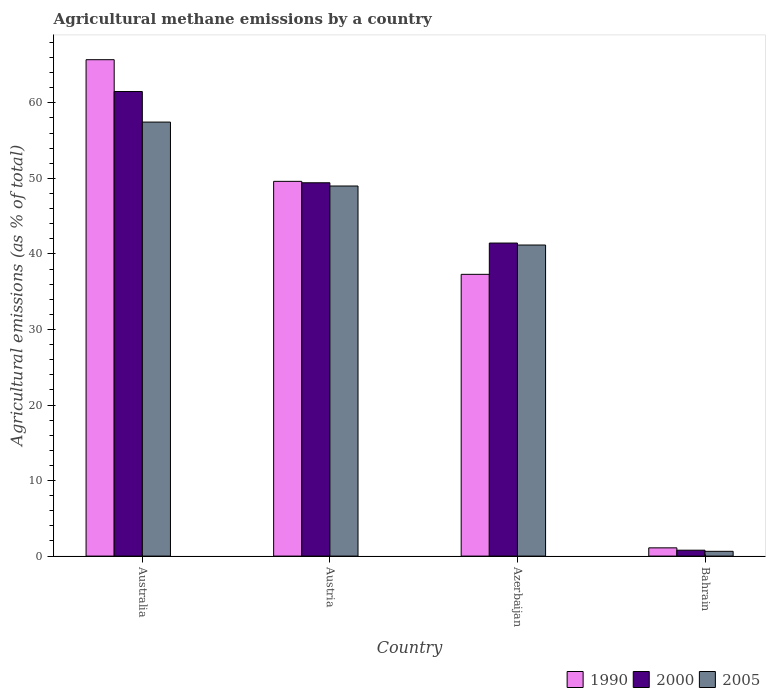Are the number of bars per tick equal to the number of legend labels?
Keep it short and to the point. Yes. How many bars are there on the 4th tick from the right?
Offer a very short reply. 3. What is the label of the 3rd group of bars from the left?
Give a very brief answer. Azerbaijan. In how many cases, is the number of bars for a given country not equal to the number of legend labels?
Offer a terse response. 0. What is the amount of agricultural methane emitted in 2005 in Austria?
Make the answer very short. 48.99. Across all countries, what is the maximum amount of agricultural methane emitted in 2005?
Offer a terse response. 57.45. Across all countries, what is the minimum amount of agricultural methane emitted in 2005?
Provide a short and direct response. 0.63. In which country was the amount of agricultural methane emitted in 1990 maximum?
Your answer should be very brief. Australia. In which country was the amount of agricultural methane emitted in 2005 minimum?
Provide a short and direct response. Bahrain. What is the total amount of agricultural methane emitted in 1990 in the graph?
Your answer should be compact. 153.71. What is the difference between the amount of agricultural methane emitted in 2005 in Australia and that in Bahrain?
Give a very brief answer. 56.82. What is the difference between the amount of agricultural methane emitted in 2005 in Azerbaijan and the amount of agricultural methane emitted in 1990 in Bahrain?
Offer a terse response. 40.09. What is the average amount of agricultural methane emitted in 2000 per country?
Give a very brief answer. 38.28. What is the difference between the amount of agricultural methane emitted of/in 2005 and amount of agricultural methane emitted of/in 2000 in Austria?
Offer a very short reply. -0.43. In how many countries, is the amount of agricultural methane emitted in 2005 greater than 44 %?
Provide a short and direct response. 2. What is the ratio of the amount of agricultural methane emitted in 2000 in Austria to that in Azerbaijan?
Make the answer very short. 1.19. What is the difference between the highest and the second highest amount of agricultural methane emitted in 2005?
Keep it short and to the point. -8.46. What is the difference between the highest and the lowest amount of agricultural methane emitted in 1990?
Ensure brevity in your answer.  64.62. In how many countries, is the amount of agricultural methane emitted in 1990 greater than the average amount of agricultural methane emitted in 1990 taken over all countries?
Offer a very short reply. 2. Is it the case that in every country, the sum of the amount of agricultural methane emitted in 2005 and amount of agricultural methane emitted in 1990 is greater than the amount of agricultural methane emitted in 2000?
Make the answer very short. Yes. How many bars are there?
Your answer should be compact. 12. Are the values on the major ticks of Y-axis written in scientific E-notation?
Your answer should be very brief. No. Does the graph contain grids?
Offer a very short reply. No. How are the legend labels stacked?
Offer a very short reply. Horizontal. What is the title of the graph?
Make the answer very short. Agricultural methane emissions by a country. What is the label or title of the Y-axis?
Your answer should be very brief. Agricultural emissions (as % of total). What is the Agricultural emissions (as % of total) of 1990 in Australia?
Your answer should be compact. 65.71. What is the Agricultural emissions (as % of total) of 2000 in Australia?
Give a very brief answer. 61.5. What is the Agricultural emissions (as % of total) in 2005 in Australia?
Provide a short and direct response. 57.45. What is the Agricultural emissions (as % of total) in 1990 in Austria?
Offer a terse response. 49.61. What is the Agricultural emissions (as % of total) of 2000 in Austria?
Provide a short and direct response. 49.42. What is the Agricultural emissions (as % of total) in 2005 in Austria?
Give a very brief answer. 48.99. What is the Agricultural emissions (as % of total) in 1990 in Azerbaijan?
Your response must be concise. 37.3. What is the Agricultural emissions (as % of total) in 2000 in Azerbaijan?
Your answer should be compact. 41.44. What is the Agricultural emissions (as % of total) in 2005 in Azerbaijan?
Keep it short and to the point. 41.18. What is the Agricultural emissions (as % of total) in 1990 in Bahrain?
Your answer should be compact. 1.09. What is the Agricultural emissions (as % of total) of 2000 in Bahrain?
Provide a short and direct response. 0.78. What is the Agricultural emissions (as % of total) of 2005 in Bahrain?
Your response must be concise. 0.63. Across all countries, what is the maximum Agricultural emissions (as % of total) in 1990?
Your response must be concise. 65.71. Across all countries, what is the maximum Agricultural emissions (as % of total) in 2000?
Offer a very short reply. 61.5. Across all countries, what is the maximum Agricultural emissions (as % of total) in 2005?
Give a very brief answer. 57.45. Across all countries, what is the minimum Agricultural emissions (as % of total) in 1990?
Keep it short and to the point. 1.09. Across all countries, what is the minimum Agricultural emissions (as % of total) in 2000?
Your response must be concise. 0.78. Across all countries, what is the minimum Agricultural emissions (as % of total) of 2005?
Provide a short and direct response. 0.63. What is the total Agricultural emissions (as % of total) in 1990 in the graph?
Your answer should be very brief. 153.71. What is the total Agricultural emissions (as % of total) in 2000 in the graph?
Make the answer very short. 153.13. What is the total Agricultural emissions (as % of total) of 2005 in the graph?
Offer a terse response. 148.25. What is the difference between the Agricultural emissions (as % of total) in 1990 in Australia and that in Austria?
Keep it short and to the point. 16.1. What is the difference between the Agricultural emissions (as % of total) in 2000 in Australia and that in Austria?
Ensure brevity in your answer.  12.08. What is the difference between the Agricultural emissions (as % of total) in 2005 in Australia and that in Austria?
Give a very brief answer. 8.46. What is the difference between the Agricultural emissions (as % of total) in 1990 in Australia and that in Azerbaijan?
Your response must be concise. 28.41. What is the difference between the Agricultural emissions (as % of total) in 2000 in Australia and that in Azerbaijan?
Give a very brief answer. 20.06. What is the difference between the Agricultural emissions (as % of total) in 2005 in Australia and that in Azerbaijan?
Make the answer very short. 16.27. What is the difference between the Agricultural emissions (as % of total) of 1990 in Australia and that in Bahrain?
Your answer should be very brief. 64.62. What is the difference between the Agricultural emissions (as % of total) of 2000 in Australia and that in Bahrain?
Give a very brief answer. 60.72. What is the difference between the Agricultural emissions (as % of total) in 2005 in Australia and that in Bahrain?
Offer a terse response. 56.82. What is the difference between the Agricultural emissions (as % of total) in 1990 in Austria and that in Azerbaijan?
Make the answer very short. 12.31. What is the difference between the Agricultural emissions (as % of total) of 2000 in Austria and that in Azerbaijan?
Provide a succinct answer. 7.98. What is the difference between the Agricultural emissions (as % of total) of 2005 in Austria and that in Azerbaijan?
Offer a very short reply. 7.81. What is the difference between the Agricultural emissions (as % of total) of 1990 in Austria and that in Bahrain?
Ensure brevity in your answer.  48.51. What is the difference between the Agricultural emissions (as % of total) in 2000 in Austria and that in Bahrain?
Provide a short and direct response. 48.64. What is the difference between the Agricultural emissions (as % of total) in 2005 in Austria and that in Bahrain?
Your answer should be very brief. 48.36. What is the difference between the Agricultural emissions (as % of total) of 1990 in Azerbaijan and that in Bahrain?
Your answer should be very brief. 36.21. What is the difference between the Agricultural emissions (as % of total) of 2000 in Azerbaijan and that in Bahrain?
Provide a short and direct response. 40.66. What is the difference between the Agricultural emissions (as % of total) in 2005 in Azerbaijan and that in Bahrain?
Your answer should be very brief. 40.54. What is the difference between the Agricultural emissions (as % of total) in 1990 in Australia and the Agricultural emissions (as % of total) in 2000 in Austria?
Make the answer very short. 16.29. What is the difference between the Agricultural emissions (as % of total) of 1990 in Australia and the Agricultural emissions (as % of total) of 2005 in Austria?
Your answer should be compact. 16.72. What is the difference between the Agricultural emissions (as % of total) of 2000 in Australia and the Agricultural emissions (as % of total) of 2005 in Austria?
Your answer should be compact. 12.51. What is the difference between the Agricultural emissions (as % of total) of 1990 in Australia and the Agricultural emissions (as % of total) of 2000 in Azerbaijan?
Offer a very short reply. 24.27. What is the difference between the Agricultural emissions (as % of total) of 1990 in Australia and the Agricultural emissions (as % of total) of 2005 in Azerbaijan?
Ensure brevity in your answer.  24.53. What is the difference between the Agricultural emissions (as % of total) in 2000 in Australia and the Agricultural emissions (as % of total) in 2005 in Azerbaijan?
Provide a succinct answer. 20.32. What is the difference between the Agricultural emissions (as % of total) in 1990 in Australia and the Agricultural emissions (as % of total) in 2000 in Bahrain?
Offer a terse response. 64.93. What is the difference between the Agricultural emissions (as % of total) of 1990 in Australia and the Agricultural emissions (as % of total) of 2005 in Bahrain?
Offer a very short reply. 65.08. What is the difference between the Agricultural emissions (as % of total) in 2000 in Australia and the Agricultural emissions (as % of total) in 2005 in Bahrain?
Provide a succinct answer. 60.86. What is the difference between the Agricultural emissions (as % of total) in 1990 in Austria and the Agricultural emissions (as % of total) in 2000 in Azerbaijan?
Keep it short and to the point. 8.17. What is the difference between the Agricultural emissions (as % of total) of 1990 in Austria and the Agricultural emissions (as % of total) of 2005 in Azerbaijan?
Your response must be concise. 8.43. What is the difference between the Agricultural emissions (as % of total) of 2000 in Austria and the Agricultural emissions (as % of total) of 2005 in Azerbaijan?
Offer a terse response. 8.24. What is the difference between the Agricultural emissions (as % of total) of 1990 in Austria and the Agricultural emissions (as % of total) of 2000 in Bahrain?
Offer a very short reply. 48.82. What is the difference between the Agricultural emissions (as % of total) of 1990 in Austria and the Agricultural emissions (as % of total) of 2005 in Bahrain?
Your answer should be very brief. 48.97. What is the difference between the Agricultural emissions (as % of total) in 2000 in Austria and the Agricultural emissions (as % of total) in 2005 in Bahrain?
Provide a succinct answer. 48.78. What is the difference between the Agricultural emissions (as % of total) in 1990 in Azerbaijan and the Agricultural emissions (as % of total) in 2000 in Bahrain?
Give a very brief answer. 36.52. What is the difference between the Agricultural emissions (as % of total) in 1990 in Azerbaijan and the Agricultural emissions (as % of total) in 2005 in Bahrain?
Make the answer very short. 36.66. What is the difference between the Agricultural emissions (as % of total) of 2000 in Azerbaijan and the Agricultural emissions (as % of total) of 2005 in Bahrain?
Your answer should be very brief. 40.8. What is the average Agricultural emissions (as % of total) in 1990 per country?
Give a very brief answer. 38.43. What is the average Agricultural emissions (as % of total) of 2000 per country?
Offer a very short reply. 38.28. What is the average Agricultural emissions (as % of total) of 2005 per country?
Ensure brevity in your answer.  37.06. What is the difference between the Agricultural emissions (as % of total) in 1990 and Agricultural emissions (as % of total) in 2000 in Australia?
Provide a short and direct response. 4.21. What is the difference between the Agricultural emissions (as % of total) of 1990 and Agricultural emissions (as % of total) of 2005 in Australia?
Your answer should be compact. 8.26. What is the difference between the Agricultural emissions (as % of total) of 2000 and Agricultural emissions (as % of total) of 2005 in Australia?
Offer a very short reply. 4.04. What is the difference between the Agricultural emissions (as % of total) of 1990 and Agricultural emissions (as % of total) of 2000 in Austria?
Provide a succinct answer. 0.19. What is the difference between the Agricultural emissions (as % of total) of 1990 and Agricultural emissions (as % of total) of 2005 in Austria?
Provide a succinct answer. 0.62. What is the difference between the Agricultural emissions (as % of total) in 2000 and Agricultural emissions (as % of total) in 2005 in Austria?
Your answer should be compact. 0.43. What is the difference between the Agricultural emissions (as % of total) of 1990 and Agricultural emissions (as % of total) of 2000 in Azerbaijan?
Your answer should be compact. -4.14. What is the difference between the Agricultural emissions (as % of total) in 1990 and Agricultural emissions (as % of total) in 2005 in Azerbaijan?
Offer a terse response. -3.88. What is the difference between the Agricultural emissions (as % of total) of 2000 and Agricultural emissions (as % of total) of 2005 in Azerbaijan?
Provide a succinct answer. 0.26. What is the difference between the Agricultural emissions (as % of total) of 1990 and Agricultural emissions (as % of total) of 2000 in Bahrain?
Keep it short and to the point. 0.31. What is the difference between the Agricultural emissions (as % of total) in 1990 and Agricultural emissions (as % of total) in 2005 in Bahrain?
Keep it short and to the point. 0.46. What is the difference between the Agricultural emissions (as % of total) in 2000 and Agricultural emissions (as % of total) in 2005 in Bahrain?
Your answer should be very brief. 0.15. What is the ratio of the Agricultural emissions (as % of total) of 1990 in Australia to that in Austria?
Your answer should be very brief. 1.32. What is the ratio of the Agricultural emissions (as % of total) of 2000 in Australia to that in Austria?
Make the answer very short. 1.24. What is the ratio of the Agricultural emissions (as % of total) in 2005 in Australia to that in Austria?
Your response must be concise. 1.17. What is the ratio of the Agricultural emissions (as % of total) in 1990 in Australia to that in Azerbaijan?
Your answer should be very brief. 1.76. What is the ratio of the Agricultural emissions (as % of total) in 2000 in Australia to that in Azerbaijan?
Offer a very short reply. 1.48. What is the ratio of the Agricultural emissions (as % of total) in 2005 in Australia to that in Azerbaijan?
Offer a very short reply. 1.4. What is the ratio of the Agricultural emissions (as % of total) in 1990 in Australia to that in Bahrain?
Give a very brief answer. 60.17. What is the ratio of the Agricultural emissions (as % of total) in 2000 in Australia to that in Bahrain?
Provide a succinct answer. 78.66. What is the ratio of the Agricultural emissions (as % of total) of 2005 in Australia to that in Bahrain?
Your answer should be compact. 90.68. What is the ratio of the Agricultural emissions (as % of total) of 1990 in Austria to that in Azerbaijan?
Offer a very short reply. 1.33. What is the ratio of the Agricultural emissions (as % of total) of 2000 in Austria to that in Azerbaijan?
Offer a terse response. 1.19. What is the ratio of the Agricultural emissions (as % of total) of 2005 in Austria to that in Azerbaijan?
Your answer should be compact. 1.19. What is the ratio of the Agricultural emissions (as % of total) in 1990 in Austria to that in Bahrain?
Your response must be concise. 45.42. What is the ratio of the Agricultural emissions (as % of total) in 2000 in Austria to that in Bahrain?
Your answer should be compact. 63.21. What is the ratio of the Agricultural emissions (as % of total) in 2005 in Austria to that in Bahrain?
Your response must be concise. 77.32. What is the ratio of the Agricultural emissions (as % of total) in 1990 in Azerbaijan to that in Bahrain?
Offer a terse response. 34.15. What is the ratio of the Agricultural emissions (as % of total) of 2000 in Azerbaijan to that in Bahrain?
Give a very brief answer. 53. What is the ratio of the Agricultural emissions (as % of total) of 2005 in Azerbaijan to that in Bahrain?
Keep it short and to the point. 64.99. What is the difference between the highest and the second highest Agricultural emissions (as % of total) of 1990?
Give a very brief answer. 16.1. What is the difference between the highest and the second highest Agricultural emissions (as % of total) in 2000?
Provide a short and direct response. 12.08. What is the difference between the highest and the second highest Agricultural emissions (as % of total) in 2005?
Your response must be concise. 8.46. What is the difference between the highest and the lowest Agricultural emissions (as % of total) in 1990?
Provide a succinct answer. 64.62. What is the difference between the highest and the lowest Agricultural emissions (as % of total) of 2000?
Give a very brief answer. 60.72. What is the difference between the highest and the lowest Agricultural emissions (as % of total) in 2005?
Your answer should be compact. 56.82. 